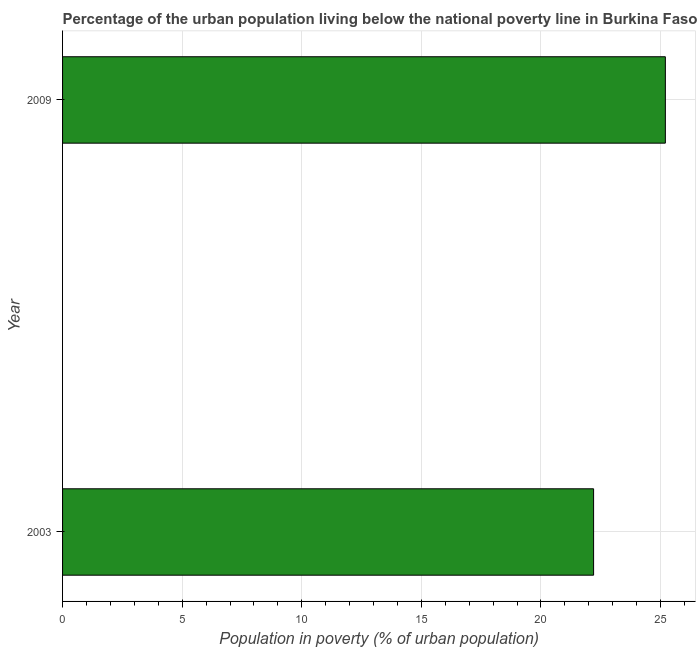Does the graph contain any zero values?
Provide a succinct answer. No. What is the title of the graph?
Offer a very short reply. Percentage of the urban population living below the national poverty line in Burkina Faso. What is the label or title of the X-axis?
Make the answer very short. Population in poverty (% of urban population). What is the label or title of the Y-axis?
Give a very brief answer. Year. What is the percentage of urban population living below poverty line in 2003?
Provide a succinct answer. 22.2. Across all years, what is the maximum percentage of urban population living below poverty line?
Give a very brief answer. 25.2. What is the sum of the percentage of urban population living below poverty line?
Give a very brief answer. 47.4. What is the difference between the percentage of urban population living below poverty line in 2003 and 2009?
Give a very brief answer. -3. What is the average percentage of urban population living below poverty line per year?
Keep it short and to the point. 23.7. What is the median percentage of urban population living below poverty line?
Give a very brief answer. 23.7. In how many years, is the percentage of urban population living below poverty line greater than 5 %?
Provide a short and direct response. 2. What is the ratio of the percentage of urban population living below poverty line in 2003 to that in 2009?
Ensure brevity in your answer.  0.88. Are all the bars in the graph horizontal?
Provide a succinct answer. Yes. Are the values on the major ticks of X-axis written in scientific E-notation?
Provide a short and direct response. No. What is the Population in poverty (% of urban population) of 2009?
Your answer should be very brief. 25.2. What is the difference between the Population in poverty (% of urban population) in 2003 and 2009?
Your response must be concise. -3. What is the ratio of the Population in poverty (% of urban population) in 2003 to that in 2009?
Provide a succinct answer. 0.88. 